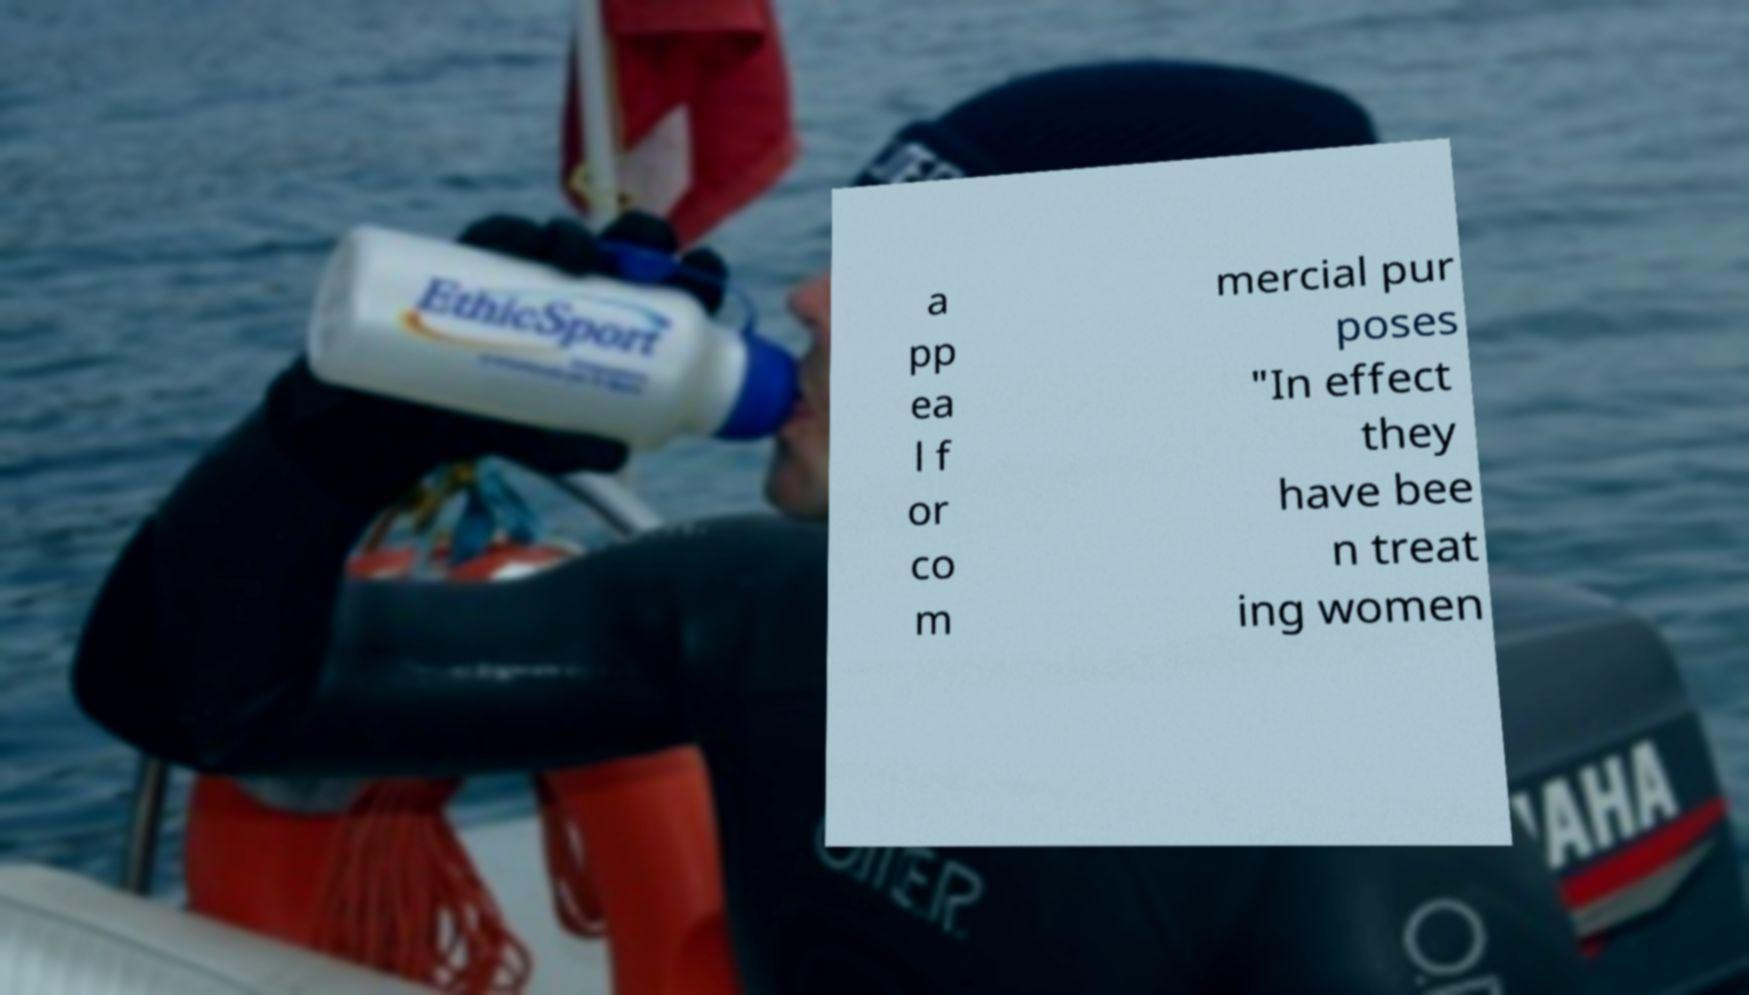Please read and relay the text visible in this image. What does it say? a pp ea l f or co m mercial pur poses "In effect they have bee n treat ing women 